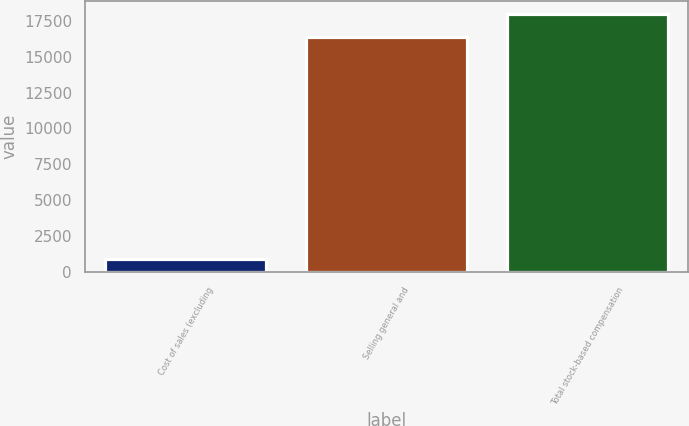<chart> <loc_0><loc_0><loc_500><loc_500><bar_chart><fcel>Cost of sales (excluding<fcel>Selling general and<fcel>Total stock-based compensation<nl><fcel>914<fcel>16336<fcel>17969.6<nl></chart> 